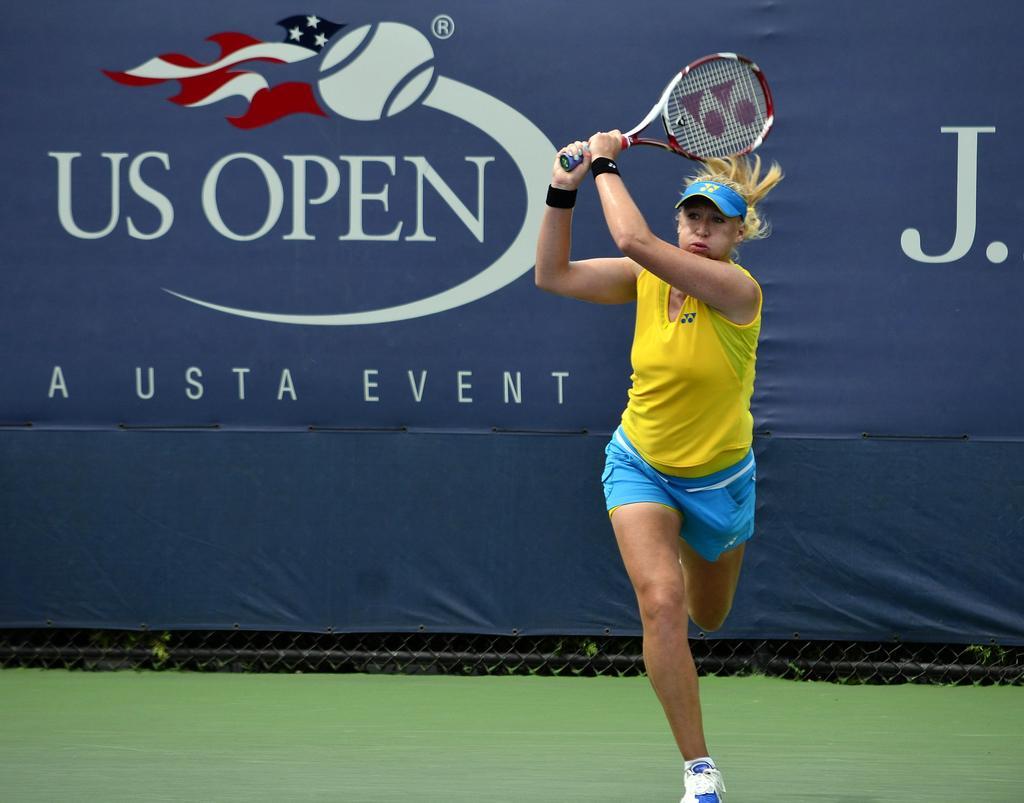Describe this image in one or two sentences. In the picture there is a player, she is holding a bat with her two hands and behind her there is a banner with some name on that. 